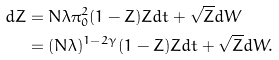Convert formula to latex. <formula><loc_0><loc_0><loc_500><loc_500>d Z & = N \lambda \pi _ { 0 } ^ { 2 } ( 1 - Z ) Z d t + \sqrt { Z } d W \\ & = ( N \lambda ) ^ { 1 - 2 \gamma } ( 1 - Z ) Z d t + \sqrt { Z } d W .</formula> 